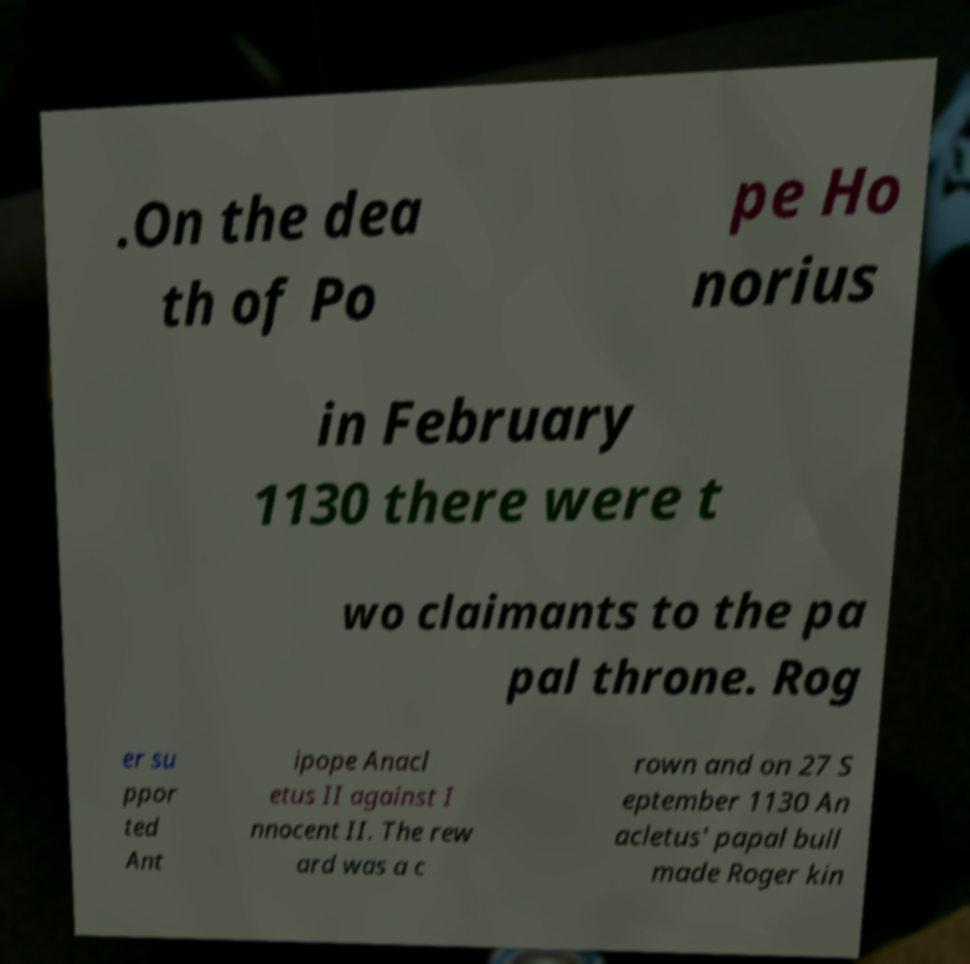Please read and relay the text visible in this image. What does it say? .On the dea th of Po pe Ho norius in February 1130 there were t wo claimants to the pa pal throne. Rog er su ppor ted Ant ipope Anacl etus II against I nnocent II. The rew ard was a c rown and on 27 S eptember 1130 An acletus' papal bull made Roger kin 